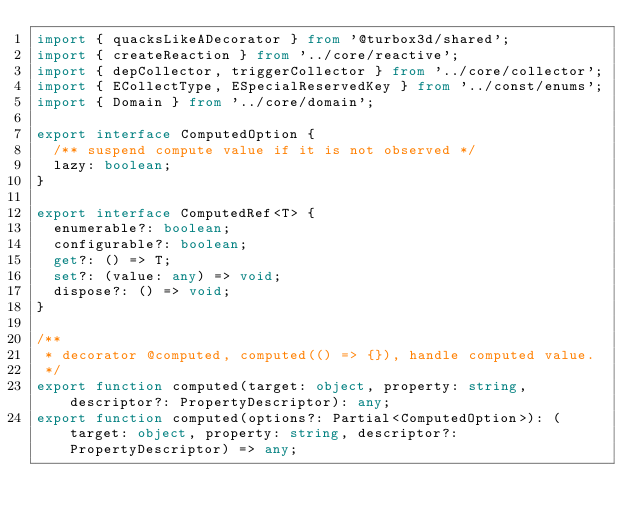<code> <loc_0><loc_0><loc_500><loc_500><_TypeScript_>import { quacksLikeADecorator } from '@turbox3d/shared';
import { createReaction } from '../core/reactive';
import { depCollector, triggerCollector } from '../core/collector';
import { ECollectType, ESpecialReservedKey } from '../const/enums';
import { Domain } from '../core/domain';

export interface ComputedOption {
  /** suspend compute value if it is not observed */
  lazy: boolean;
}

export interface ComputedRef<T> {
  enumerable?: boolean;
  configurable?: boolean;
  get?: () => T;
  set?: (value: any) => void;
  dispose?: () => void;
}

/**
 * decorator @computed, computed(() => {}), handle computed value.
 */
export function computed(target: object, property: string, descriptor?: PropertyDescriptor): any;
export function computed(options?: Partial<ComputedOption>): (target: object, property: string, descriptor?: PropertyDescriptor) => any;</code> 